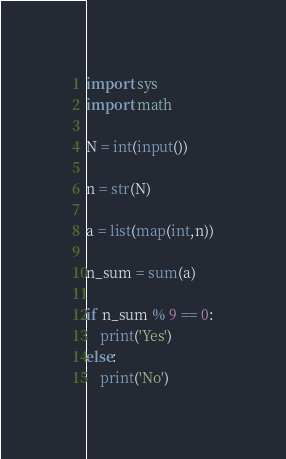Convert code to text. <code><loc_0><loc_0><loc_500><loc_500><_Python_>import sys
import math

N = int(input())

n = str(N)

a = list(map(int,n))

n_sum = sum(a)

if n_sum % 9 == 0:
    print('Yes')
else:
    print('No')</code> 